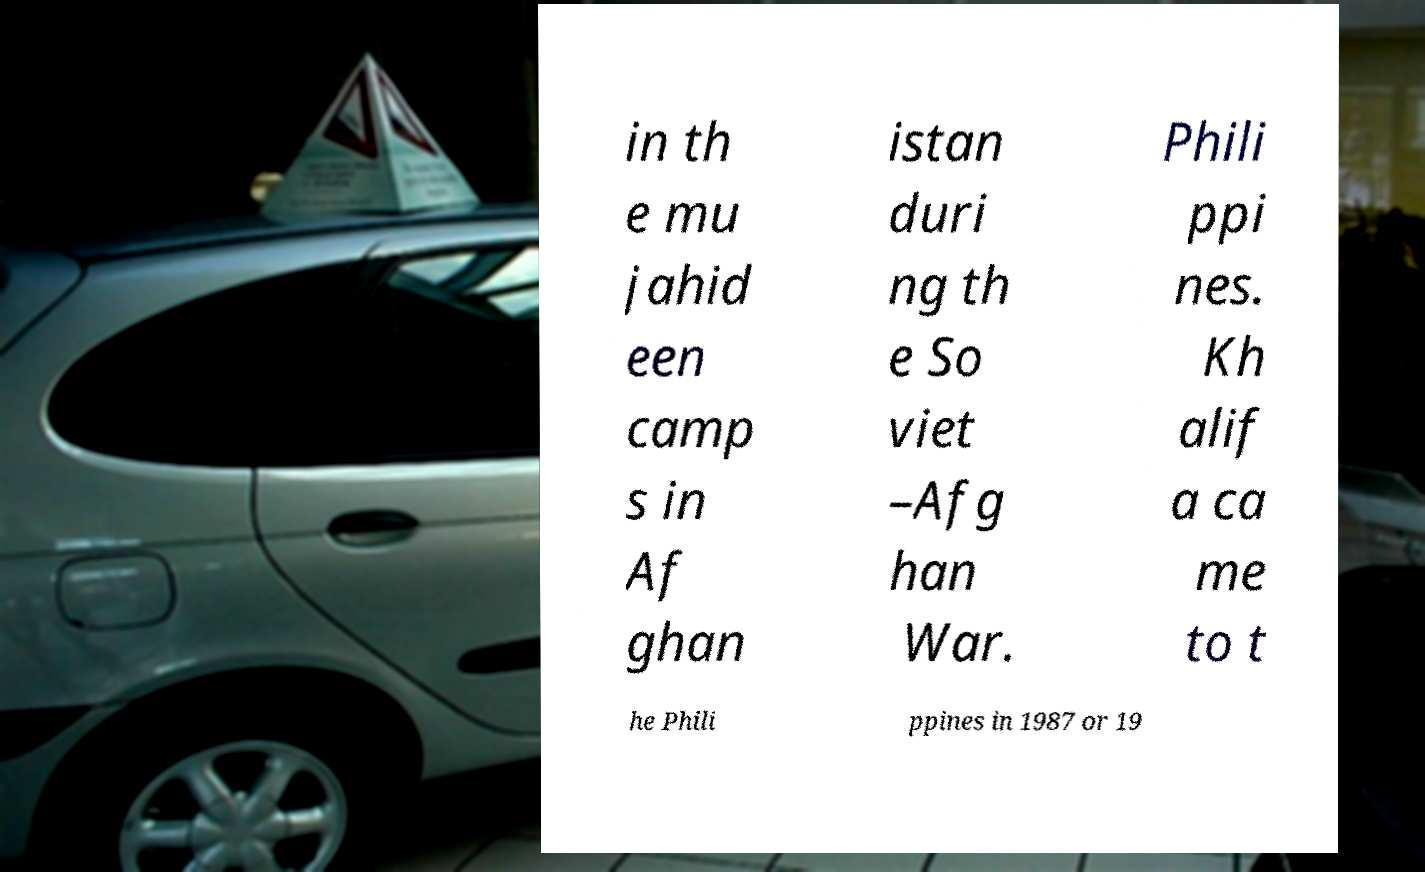Please identify and transcribe the text found in this image. in th e mu jahid een camp s in Af ghan istan duri ng th e So viet –Afg han War. Phili ppi nes. Kh alif a ca me to t he Phili ppines in 1987 or 19 